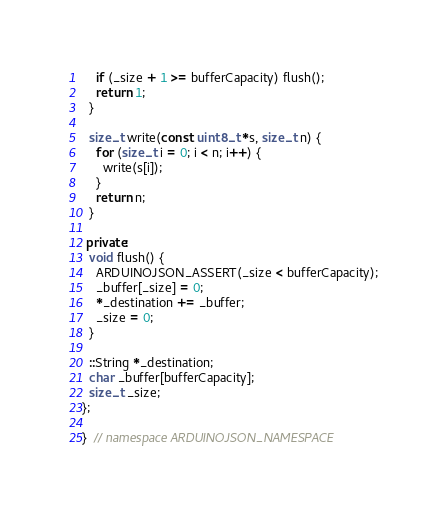Convert code to text. <code><loc_0><loc_0><loc_500><loc_500><_C++_>    if (_size + 1 >= bufferCapacity) flush();
    return 1;
  }

  size_t write(const uint8_t *s, size_t n) {
    for (size_t i = 0; i < n; i++) {
      write(s[i]);
    }
    return n;
  }

 private:
  void flush() {
    ARDUINOJSON_ASSERT(_size < bufferCapacity);
    _buffer[_size] = 0;
    *_destination += _buffer;
    _size = 0;
  }

  ::String *_destination;
  char _buffer[bufferCapacity];
  size_t _size;
};

}  // namespace ARDUINOJSON_NAMESPACE
</code> 